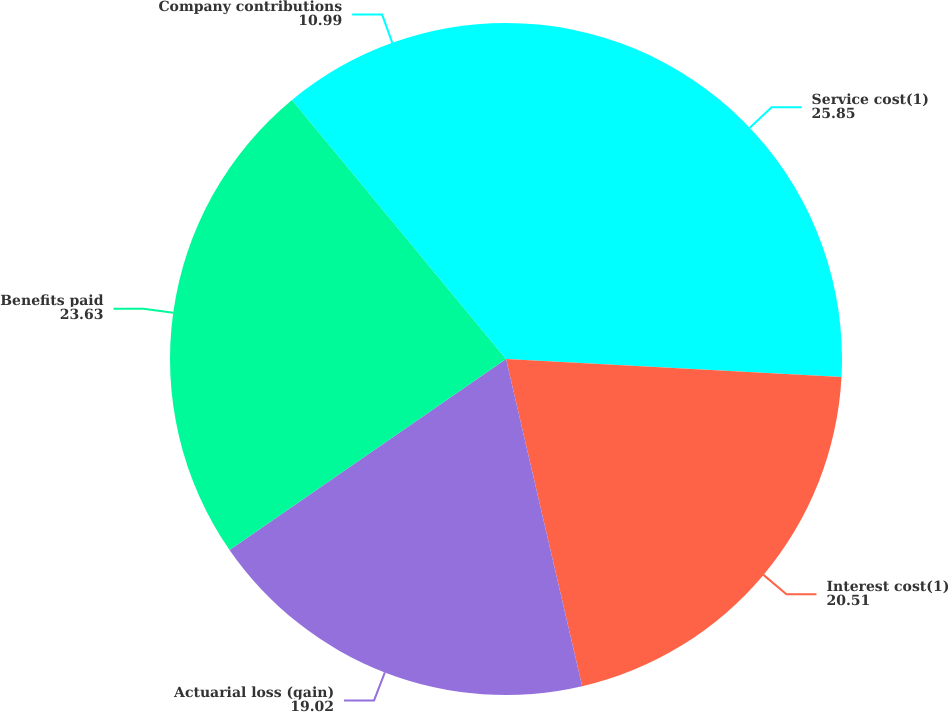Convert chart. <chart><loc_0><loc_0><loc_500><loc_500><pie_chart><fcel>Service cost(1)<fcel>Interest cost(1)<fcel>Actuarial loss (gain)<fcel>Benefits paid<fcel>Company contributions<nl><fcel>25.85%<fcel>20.51%<fcel>19.02%<fcel>23.63%<fcel>10.99%<nl></chart> 